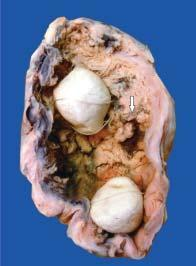how many multi-faceted gallstones are also present in the lumen?
Answer the question using a single word or phrase. Two 